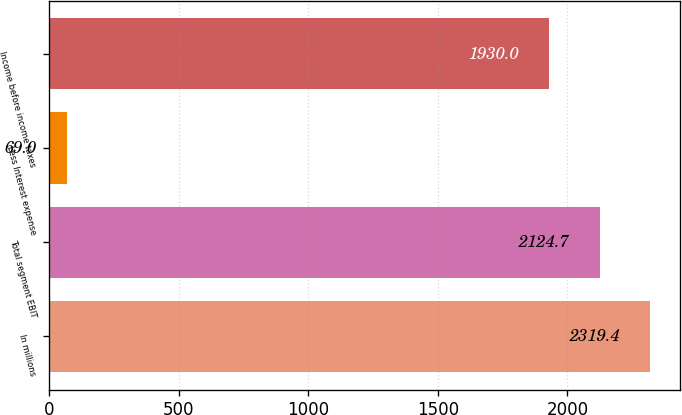Convert chart. <chart><loc_0><loc_0><loc_500><loc_500><bar_chart><fcel>In millions<fcel>Total segment EBIT<fcel>Less Interest expense<fcel>Income before income taxes<nl><fcel>2319.4<fcel>2124.7<fcel>69<fcel>1930<nl></chart> 